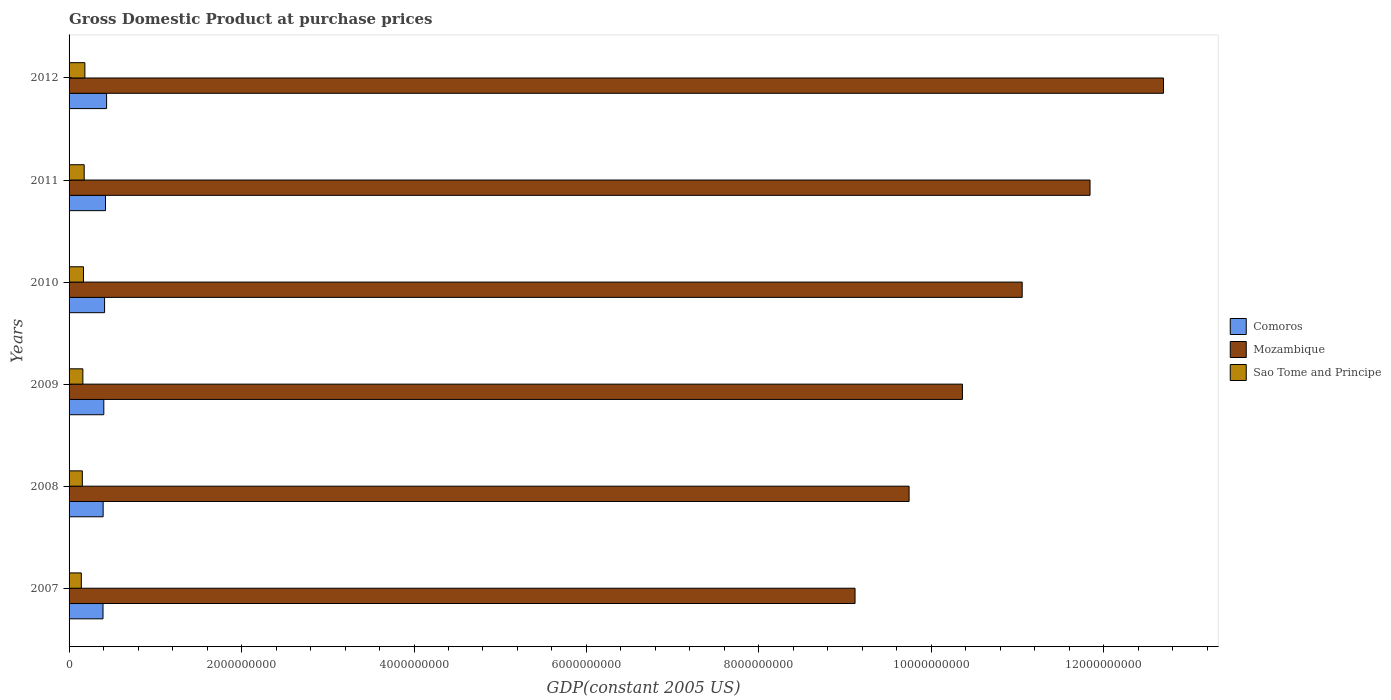How many different coloured bars are there?
Provide a short and direct response. 3. How many groups of bars are there?
Make the answer very short. 6. Are the number of bars on each tick of the Y-axis equal?
Your response must be concise. Yes. How many bars are there on the 3rd tick from the top?
Your answer should be very brief. 3. How many bars are there on the 5th tick from the bottom?
Your answer should be very brief. 3. What is the label of the 6th group of bars from the top?
Provide a short and direct response. 2007. In how many cases, is the number of bars for a given year not equal to the number of legend labels?
Provide a short and direct response. 0. What is the GDP at purchase prices in Comoros in 2008?
Your response must be concise. 3.95e+08. Across all years, what is the maximum GDP at purchase prices in Sao Tome and Principe?
Offer a terse response. 1.83e+08. Across all years, what is the minimum GDP at purchase prices in Sao Tome and Principe?
Give a very brief answer. 1.42e+08. In which year was the GDP at purchase prices in Mozambique maximum?
Your answer should be compact. 2012. What is the total GDP at purchase prices in Sao Tome and Principe in the graph?
Offer a very short reply. 9.82e+08. What is the difference between the GDP at purchase prices in Mozambique in 2007 and that in 2012?
Your response must be concise. -3.58e+09. What is the difference between the GDP at purchase prices in Comoros in 2010 and the GDP at purchase prices in Mozambique in 2012?
Offer a very short reply. -1.23e+1. What is the average GDP at purchase prices in Sao Tome and Principe per year?
Your answer should be compact. 1.64e+08. In the year 2007, what is the difference between the GDP at purchase prices in Mozambique and GDP at purchase prices in Sao Tome and Principe?
Your answer should be very brief. 8.97e+09. In how many years, is the GDP at purchase prices in Mozambique greater than 6800000000 US$?
Offer a terse response. 6. What is the ratio of the GDP at purchase prices in Mozambique in 2009 to that in 2012?
Your response must be concise. 0.82. Is the GDP at purchase prices in Mozambique in 2010 less than that in 2012?
Your answer should be very brief. Yes. Is the difference between the GDP at purchase prices in Mozambique in 2009 and 2010 greater than the difference between the GDP at purchase prices in Sao Tome and Principe in 2009 and 2010?
Provide a short and direct response. No. What is the difference between the highest and the second highest GDP at purchase prices in Sao Tome and Principe?
Offer a terse response. 8.04e+06. What is the difference between the highest and the lowest GDP at purchase prices in Sao Tome and Principe?
Offer a very short reply. 4.11e+07. Is the sum of the GDP at purchase prices in Mozambique in 2010 and 2012 greater than the maximum GDP at purchase prices in Sao Tome and Principe across all years?
Make the answer very short. Yes. What does the 3rd bar from the top in 2009 represents?
Make the answer very short. Comoros. What does the 1st bar from the bottom in 2010 represents?
Offer a terse response. Comoros. How many bars are there?
Your answer should be compact. 18. How many years are there in the graph?
Make the answer very short. 6. What is the difference between two consecutive major ticks on the X-axis?
Give a very brief answer. 2.00e+09. Are the values on the major ticks of X-axis written in scientific E-notation?
Provide a short and direct response. No. Does the graph contain any zero values?
Ensure brevity in your answer.  No. Does the graph contain grids?
Provide a succinct answer. No. How are the legend labels stacked?
Offer a terse response. Vertical. What is the title of the graph?
Ensure brevity in your answer.  Gross Domestic Product at purchase prices. Does "Kiribati" appear as one of the legend labels in the graph?
Provide a short and direct response. No. What is the label or title of the X-axis?
Your answer should be very brief. GDP(constant 2005 US). What is the label or title of the Y-axis?
Your answer should be compact. Years. What is the GDP(constant 2005 US) of Comoros in 2007?
Your answer should be compact. 3.94e+08. What is the GDP(constant 2005 US) in Mozambique in 2007?
Keep it short and to the point. 9.11e+09. What is the GDP(constant 2005 US) in Sao Tome and Principe in 2007?
Make the answer very short. 1.42e+08. What is the GDP(constant 2005 US) in Comoros in 2008?
Provide a succinct answer. 3.95e+08. What is the GDP(constant 2005 US) in Mozambique in 2008?
Your response must be concise. 9.74e+09. What is the GDP(constant 2005 US) of Sao Tome and Principe in 2008?
Provide a short and direct response. 1.54e+08. What is the GDP(constant 2005 US) of Comoros in 2009?
Offer a very short reply. 4.03e+08. What is the GDP(constant 2005 US) in Mozambique in 2009?
Your answer should be very brief. 1.04e+1. What is the GDP(constant 2005 US) in Sao Tome and Principe in 2009?
Your answer should be compact. 1.60e+08. What is the GDP(constant 2005 US) in Comoros in 2010?
Offer a terse response. 4.12e+08. What is the GDP(constant 2005 US) in Mozambique in 2010?
Your response must be concise. 1.11e+1. What is the GDP(constant 2005 US) of Sao Tome and Principe in 2010?
Ensure brevity in your answer.  1.67e+08. What is the GDP(constant 2005 US) in Comoros in 2011?
Your response must be concise. 4.22e+08. What is the GDP(constant 2005 US) of Mozambique in 2011?
Your answer should be very brief. 1.18e+1. What is the GDP(constant 2005 US) in Sao Tome and Principe in 2011?
Your answer should be compact. 1.75e+08. What is the GDP(constant 2005 US) in Comoros in 2012?
Provide a succinct answer. 4.35e+08. What is the GDP(constant 2005 US) of Mozambique in 2012?
Your answer should be compact. 1.27e+1. What is the GDP(constant 2005 US) of Sao Tome and Principe in 2012?
Make the answer very short. 1.83e+08. Across all years, what is the maximum GDP(constant 2005 US) of Comoros?
Your answer should be compact. 4.35e+08. Across all years, what is the maximum GDP(constant 2005 US) of Mozambique?
Provide a succinct answer. 1.27e+1. Across all years, what is the maximum GDP(constant 2005 US) in Sao Tome and Principe?
Provide a short and direct response. 1.83e+08. Across all years, what is the minimum GDP(constant 2005 US) of Comoros?
Provide a succinct answer. 3.94e+08. Across all years, what is the minimum GDP(constant 2005 US) in Mozambique?
Your answer should be very brief. 9.11e+09. Across all years, what is the minimum GDP(constant 2005 US) in Sao Tome and Principe?
Give a very brief answer. 1.42e+08. What is the total GDP(constant 2005 US) in Comoros in the graph?
Provide a short and direct response. 2.46e+09. What is the total GDP(constant 2005 US) in Mozambique in the graph?
Keep it short and to the point. 6.48e+1. What is the total GDP(constant 2005 US) of Sao Tome and Principe in the graph?
Offer a terse response. 9.82e+08. What is the difference between the GDP(constant 2005 US) in Comoros in 2007 and that in 2008?
Your response must be concise. -1.58e+06. What is the difference between the GDP(constant 2005 US) of Mozambique in 2007 and that in 2008?
Ensure brevity in your answer.  -6.27e+08. What is the difference between the GDP(constant 2005 US) in Sao Tome and Principe in 2007 and that in 2008?
Give a very brief answer. -1.16e+07. What is the difference between the GDP(constant 2005 US) in Comoros in 2007 and that in 2009?
Your response must be concise. -9.28e+06. What is the difference between the GDP(constant 2005 US) of Mozambique in 2007 and that in 2009?
Provide a succinct answer. -1.25e+09. What is the difference between the GDP(constant 2005 US) of Sao Tome and Principe in 2007 and that in 2009?
Provide a succinct answer. -1.78e+07. What is the difference between the GDP(constant 2005 US) of Comoros in 2007 and that in 2010?
Provide a succinct answer. -1.81e+07. What is the difference between the GDP(constant 2005 US) of Mozambique in 2007 and that in 2010?
Your answer should be compact. -1.94e+09. What is the difference between the GDP(constant 2005 US) in Sao Tome and Principe in 2007 and that in 2010?
Provide a short and direct response. -2.50e+07. What is the difference between the GDP(constant 2005 US) of Comoros in 2007 and that in 2011?
Provide a short and direct response. -2.88e+07. What is the difference between the GDP(constant 2005 US) in Mozambique in 2007 and that in 2011?
Ensure brevity in your answer.  -2.73e+09. What is the difference between the GDP(constant 2005 US) in Sao Tome and Principe in 2007 and that in 2011?
Ensure brevity in your answer.  -3.31e+07. What is the difference between the GDP(constant 2005 US) of Comoros in 2007 and that in 2012?
Provide a succinct answer. -4.15e+07. What is the difference between the GDP(constant 2005 US) of Mozambique in 2007 and that in 2012?
Provide a short and direct response. -3.58e+09. What is the difference between the GDP(constant 2005 US) in Sao Tome and Principe in 2007 and that in 2012?
Provide a succinct answer. -4.11e+07. What is the difference between the GDP(constant 2005 US) in Comoros in 2008 and that in 2009?
Your answer should be very brief. -7.71e+06. What is the difference between the GDP(constant 2005 US) in Mozambique in 2008 and that in 2009?
Give a very brief answer. -6.19e+08. What is the difference between the GDP(constant 2005 US) of Sao Tome and Principe in 2008 and that in 2009?
Offer a terse response. -6.18e+06. What is the difference between the GDP(constant 2005 US) in Comoros in 2008 and that in 2010?
Your answer should be very brief. -1.66e+07. What is the difference between the GDP(constant 2005 US) of Mozambique in 2008 and that in 2010?
Keep it short and to the point. -1.31e+09. What is the difference between the GDP(constant 2005 US) in Sao Tome and Principe in 2008 and that in 2010?
Make the answer very short. -1.33e+07. What is the difference between the GDP(constant 2005 US) in Comoros in 2008 and that in 2011?
Offer a terse response. -2.73e+07. What is the difference between the GDP(constant 2005 US) of Mozambique in 2008 and that in 2011?
Your answer should be compact. -2.10e+09. What is the difference between the GDP(constant 2005 US) of Sao Tome and Principe in 2008 and that in 2011?
Ensure brevity in your answer.  -2.14e+07. What is the difference between the GDP(constant 2005 US) in Comoros in 2008 and that in 2012?
Keep it short and to the point. -3.99e+07. What is the difference between the GDP(constant 2005 US) in Mozambique in 2008 and that in 2012?
Your answer should be very brief. -2.95e+09. What is the difference between the GDP(constant 2005 US) of Sao Tome and Principe in 2008 and that in 2012?
Provide a short and direct response. -2.95e+07. What is the difference between the GDP(constant 2005 US) in Comoros in 2009 and that in 2010?
Your response must be concise. -8.86e+06. What is the difference between the GDP(constant 2005 US) in Mozambique in 2009 and that in 2010?
Provide a succinct answer. -6.93e+08. What is the difference between the GDP(constant 2005 US) of Sao Tome and Principe in 2009 and that in 2010?
Offer a very short reply. -7.17e+06. What is the difference between the GDP(constant 2005 US) of Comoros in 2009 and that in 2011?
Your answer should be very brief. -1.96e+07. What is the difference between the GDP(constant 2005 US) of Mozambique in 2009 and that in 2011?
Keep it short and to the point. -1.48e+09. What is the difference between the GDP(constant 2005 US) of Sao Tome and Principe in 2009 and that in 2011?
Give a very brief answer. -1.52e+07. What is the difference between the GDP(constant 2005 US) in Comoros in 2009 and that in 2012?
Keep it short and to the point. -3.22e+07. What is the difference between the GDP(constant 2005 US) of Mozambique in 2009 and that in 2012?
Give a very brief answer. -2.33e+09. What is the difference between the GDP(constant 2005 US) of Sao Tome and Principe in 2009 and that in 2012?
Offer a very short reply. -2.33e+07. What is the difference between the GDP(constant 2005 US) of Comoros in 2010 and that in 2011?
Keep it short and to the point. -1.07e+07. What is the difference between the GDP(constant 2005 US) of Mozambique in 2010 and that in 2011?
Offer a terse response. -7.87e+08. What is the difference between the GDP(constant 2005 US) in Sao Tome and Principe in 2010 and that in 2011?
Ensure brevity in your answer.  -8.07e+06. What is the difference between the GDP(constant 2005 US) in Comoros in 2010 and that in 2012?
Your answer should be compact. -2.34e+07. What is the difference between the GDP(constant 2005 US) of Mozambique in 2010 and that in 2012?
Offer a terse response. -1.64e+09. What is the difference between the GDP(constant 2005 US) in Sao Tome and Principe in 2010 and that in 2012?
Provide a succinct answer. -1.61e+07. What is the difference between the GDP(constant 2005 US) in Comoros in 2011 and that in 2012?
Give a very brief answer. -1.27e+07. What is the difference between the GDP(constant 2005 US) of Mozambique in 2011 and that in 2012?
Offer a very short reply. -8.52e+08. What is the difference between the GDP(constant 2005 US) of Sao Tome and Principe in 2011 and that in 2012?
Provide a succinct answer. -8.04e+06. What is the difference between the GDP(constant 2005 US) in Comoros in 2007 and the GDP(constant 2005 US) in Mozambique in 2008?
Make the answer very short. -9.35e+09. What is the difference between the GDP(constant 2005 US) of Comoros in 2007 and the GDP(constant 2005 US) of Sao Tome and Principe in 2008?
Provide a succinct answer. 2.40e+08. What is the difference between the GDP(constant 2005 US) of Mozambique in 2007 and the GDP(constant 2005 US) of Sao Tome and Principe in 2008?
Provide a short and direct response. 8.96e+09. What is the difference between the GDP(constant 2005 US) of Comoros in 2007 and the GDP(constant 2005 US) of Mozambique in 2009?
Offer a very short reply. -9.97e+09. What is the difference between the GDP(constant 2005 US) in Comoros in 2007 and the GDP(constant 2005 US) in Sao Tome and Principe in 2009?
Make the answer very short. 2.34e+08. What is the difference between the GDP(constant 2005 US) of Mozambique in 2007 and the GDP(constant 2005 US) of Sao Tome and Principe in 2009?
Keep it short and to the point. 8.95e+09. What is the difference between the GDP(constant 2005 US) in Comoros in 2007 and the GDP(constant 2005 US) in Mozambique in 2010?
Make the answer very short. -1.07e+1. What is the difference between the GDP(constant 2005 US) in Comoros in 2007 and the GDP(constant 2005 US) in Sao Tome and Principe in 2010?
Make the answer very short. 2.26e+08. What is the difference between the GDP(constant 2005 US) of Mozambique in 2007 and the GDP(constant 2005 US) of Sao Tome and Principe in 2010?
Offer a terse response. 8.95e+09. What is the difference between the GDP(constant 2005 US) in Comoros in 2007 and the GDP(constant 2005 US) in Mozambique in 2011?
Offer a terse response. -1.14e+1. What is the difference between the GDP(constant 2005 US) of Comoros in 2007 and the GDP(constant 2005 US) of Sao Tome and Principe in 2011?
Provide a short and direct response. 2.18e+08. What is the difference between the GDP(constant 2005 US) in Mozambique in 2007 and the GDP(constant 2005 US) in Sao Tome and Principe in 2011?
Your response must be concise. 8.94e+09. What is the difference between the GDP(constant 2005 US) in Comoros in 2007 and the GDP(constant 2005 US) in Mozambique in 2012?
Your answer should be very brief. -1.23e+1. What is the difference between the GDP(constant 2005 US) of Comoros in 2007 and the GDP(constant 2005 US) of Sao Tome and Principe in 2012?
Provide a succinct answer. 2.10e+08. What is the difference between the GDP(constant 2005 US) in Mozambique in 2007 and the GDP(constant 2005 US) in Sao Tome and Principe in 2012?
Ensure brevity in your answer.  8.93e+09. What is the difference between the GDP(constant 2005 US) of Comoros in 2008 and the GDP(constant 2005 US) of Mozambique in 2009?
Ensure brevity in your answer.  -9.97e+09. What is the difference between the GDP(constant 2005 US) in Comoros in 2008 and the GDP(constant 2005 US) in Sao Tome and Principe in 2009?
Your response must be concise. 2.35e+08. What is the difference between the GDP(constant 2005 US) in Mozambique in 2008 and the GDP(constant 2005 US) in Sao Tome and Principe in 2009?
Make the answer very short. 9.58e+09. What is the difference between the GDP(constant 2005 US) in Comoros in 2008 and the GDP(constant 2005 US) in Mozambique in 2010?
Provide a succinct answer. -1.07e+1. What is the difference between the GDP(constant 2005 US) in Comoros in 2008 and the GDP(constant 2005 US) in Sao Tome and Principe in 2010?
Your answer should be compact. 2.28e+08. What is the difference between the GDP(constant 2005 US) in Mozambique in 2008 and the GDP(constant 2005 US) in Sao Tome and Principe in 2010?
Your answer should be very brief. 9.57e+09. What is the difference between the GDP(constant 2005 US) in Comoros in 2008 and the GDP(constant 2005 US) in Mozambique in 2011?
Your response must be concise. -1.14e+1. What is the difference between the GDP(constant 2005 US) of Comoros in 2008 and the GDP(constant 2005 US) of Sao Tome and Principe in 2011?
Provide a short and direct response. 2.20e+08. What is the difference between the GDP(constant 2005 US) in Mozambique in 2008 and the GDP(constant 2005 US) in Sao Tome and Principe in 2011?
Give a very brief answer. 9.57e+09. What is the difference between the GDP(constant 2005 US) in Comoros in 2008 and the GDP(constant 2005 US) in Mozambique in 2012?
Your answer should be very brief. -1.23e+1. What is the difference between the GDP(constant 2005 US) in Comoros in 2008 and the GDP(constant 2005 US) in Sao Tome and Principe in 2012?
Your answer should be very brief. 2.12e+08. What is the difference between the GDP(constant 2005 US) in Mozambique in 2008 and the GDP(constant 2005 US) in Sao Tome and Principe in 2012?
Keep it short and to the point. 9.56e+09. What is the difference between the GDP(constant 2005 US) in Comoros in 2009 and the GDP(constant 2005 US) in Mozambique in 2010?
Give a very brief answer. -1.07e+1. What is the difference between the GDP(constant 2005 US) of Comoros in 2009 and the GDP(constant 2005 US) of Sao Tome and Principe in 2010?
Your answer should be compact. 2.36e+08. What is the difference between the GDP(constant 2005 US) in Mozambique in 2009 and the GDP(constant 2005 US) in Sao Tome and Principe in 2010?
Offer a terse response. 1.02e+1. What is the difference between the GDP(constant 2005 US) of Comoros in 2009 and the GDP(constant 2005 US) of Mozambique in 2011?
Offer a terse response. -1.14e+1. What is the difference between the GDP(constant 2005 US) in Comoros in 2009 and the GDP(constant 2005 US) in Sao Tome and Principe in 2011?
Give a very brief answer. 2.28e+08. What is the difference between the GDP(constant 2005 US) in Mozambique in 2009 and the GDP(constant 2005 US) in Sao Tome and Principe in 2011?
Offer a terse response. 1.02e+1. What is the difference between the GDP(constant 2005 US) of Comoros in 2009 and the GDP(constant 2005 US) of Mozambique in 2012?
Make the answer very short. -1.23e+1. What is the difference between the GDP(constant 2005 US) of Comoros in 2009 and the GDP(constant 2005 US) of Sao Tome and Principe in 2012?
Ensure brevity in your answer.  2.20e+08. What is the difference between the GDP(constant 2005 US) of Mozambique in 2009 and the GDP(constant 2005 US) of Sao Tome and Principe in 2012?
Offer a terse response. 1.02e+1. What is the difference between the GDP(constant 2005 US) in Comoros in 2010 and the GDP(constant 2005 US) in Mozambique in 2011?
Offer a very short reply. -1.14e+1. What is the difference between the GDP(constant 2005 US) of Comoros in 2010 and the GDP(constant 2005 US) of Sao Tome and Principe in 2011?
Provide a succinct answer. 2.36e+08. What is the difference between the GDP(constant 2005 US) in Mozambique in 2010 and the GDP(constant 2005 US) in Sao Tome and Principe in 2011?
Your response must be concise. 1.09e+1. What is the difference between the GDP(constant 2005 US) in Comoros in 2010 and the GDP(constant 2005 US) in Mozambique in 2012?
Give a very brief answer. -1.23e+1. What is the difference between the GDP(constant 2005 US) of Comoros in 2010 and the GDP(constant 2005 US) of Sao Tome and Principe in 2012?
Your answer should be very brief. 2.28e+08. What is the difference between the GDP(constant 2005 US) of Mozambique in 2010 and the GDP(constant 2005 US) of Sao Tome and Principe in 2012?
Make the answer very short. 1.09e+1. What is the difference between the GDP(constant 2005 US) of Comoros in 2011 and the GDP(constant 2005 US) of Mozambique in 2012?
Ensure brevity in your answer.  -1.23e+1. What is the difference between the GDP(constant 2005 US) of Comoros in 2011 and the GDP(constant 2005 US) of Sao Tome and Principe in 2012?
Keep it short and to the point. 2.39e+08. What is the difference between the GDP(constant 2005 US) of Mozambique in 2011 and the GDP(constant 2005 US) of Sao Tome and Principe in 2012?
Your answer should be compact. 1.17e+1. What is the average GDP(constant 2005 US) of Comoros per year?
Your response must be concise. 4.10e+08. What is the average GDP(constant 2005 US) in Mozambique per year?
Make the answer very short. 1.08e+1. What is the average GDP(constant 2005 US) in Sao Tome and Principe per year?
Offer a very short reply. 1.64e+08. In the year 2007, what is the difference between the GDP(constant 2005 US) in Comoros and GDP(constant 2005 US) in Mozambique?
Keep it short and to the point. -8.72e+09. In the year 2007, what is the difference between the GDP(constant 2005 US) of Comoros and GDP(constant 2005 US) of Sao Tome and Principe?
Your answer should be compact. 2.51e+08. In the year 2007, what is the difference between the GDP(constant 2005 US) in Mozambique and GDP(constant 2005 US) in Sao Tome and Principe?
Offer a terse response. 8.97e+09. In the year 2008, what is the difference between the GDP(constant 2005 US) in Comoros and GDP(constant 2005 US) in Mozambique?
Provide a succinct answer. -9.35e+09. In the year 2008, what is the difference between the GDP(constant 2005 US) of Comoros and GDP(constant 2005 US) of Sao Tome and Principe?
Provide a short and direct response. 2.41e+08. In the year 2008, what is the difference between the GDP(constant 2005 US) in Mozambique and GDP(constant 2005 US) in Sao Tome and Principe?
Your response must be concise. 9.59e+09. In the year 2009, what is the difference between the GDP(constant 2005 US) of Comoros and GDP(constant 2005 US) of Mozambique?
Make the answer very short. -9.96e+09. In the year 2009, what is the difference between the GDP(constant 2005 US) of Comoros and GDP(constant 2005 US) of Sao Tome and Principe?
Offer a terse response. 2.43e+08. In the year 2009, what is the difference between the GDP(constant 2005 US) of Mozambique and GDP(constant 2005 US) of Sao Tome and Principe?
Give a very brief answer. 1.02e+1. In the year 2010, what is the difference between the GDP(constant 2005 US) in Comoros and GDP(constant 2005 US) in Mozambique?
Keep it short and to the point. -1.06e+1. In the year 2010, what is the difference between the GDP(constant 2005 US) in Comoros and GDP(constant 2005 US) in Sao Tome and Principe?
Ensure brevity in your answer.  2.45e+08. In the year 2010, what is the difference between the GDP(constant 2005 US) in Mozambique and GDP(constant 2005 US) in Sao Tome and Principe?
Ensure brevity in your answer.  1.09e+1. In the year 2011, what is the difference between the GDP(constant 2005 US) in Comoros and GDP(constant 2005 US) in Mozambique?
Offer a terse response. -1.14e+1. In the year 2011, what is the difference between the GDP(constant 2005 US) in Comoros and GDP(constant 2005 US) in Sao Tome and Principe?
Provide a succinct answer. 2.47e+08. In the year 2011, what is the difference between the GDP(constant 2005 US) in Mozambique and GDP(constant 2005 US) in Sao Tome and Principe?
Make the answer very short. 1.17e+1. In the year 2012, what is the difference between the GDP(constant 2005 US) of Comoros and GDP(constant 2005 US) of Mozambique?
Your response must be concise. -1.23e+1. In the year 2012, what is the difference between the GDP(constant 2005 US) of Comoros and GDP(constant 2005 US) of Sao Tome and Principe?
Provide a succinct answer. 2.52e+08. In the year 2012, what is the difference between the GDP(constant 2005 US) in Mozambique and GDP(constant 2005 US) in Sao Tome and Principe?
Offer a terse response. 1.25e+1. What is the ratio of the GDP(constant 2005 US) in Mozambique in 2007 to that in 2008?
Make the answer very short. 0.94. What is the ratio of the GDP(constant 2005 US) in Sao Tome and Principe in 2007 to that in 2008?
Offer a very short reply. 0.92. What is the ratio of the GDP(constant 2005 US) of Comoros in 2007 to that in 2009?
Ensure brevity in your answer.  0.98. What is the ratio of the GDP(constant 2005 US) in Mozambique in 2007 to that in 2009?
Ensure brevity in your answer.  0.88. What is the ratio of the GDP(constant 2005 US) of Sao Tome and Principe in 2007 to that in 2009?
Provide a succinct answer. 0.89. What is the ratio of the GDP(constant 2005 US) of Comoros in 2007 to that in 2010?
Your answer should be compact. 0.96. What is the ratio of the GDP(constant 2005 US) in Mozambique in 2007 to that in 2010?
Give a very brief answer. 0.82. What is the ratio of the GDP(constant 2005 US) in Sao Tome and Principe in 2007 to that in 2010?
Make the answer very short. 0.85. What is the ratio of the GDP(constant 2005 US) of Comoros in 2007 to that in 2011?
Offer a terse response. 0.93. What is the ratio of the GDP(constant 2005 US) of Mozambique in 2007 to that in 2011?
Offer a terse response. 0.77. What is the ratio of the GDP(constant 2005 US) in Sao Tome and Principe in 2007 to that in 2011?
Your answer should be very brief. 0.81. What is the ratio of the GDP(constant 2005 US) of Comoros in 2007 to that in 2012?
Give a very brief answer. 0.9. What is the ratio of the GDP(constant 2005 US) of Mozambique in 2007 to that in 2012?
Provide a short and direct response. 0.72. What is the ratio of the GDP(constant 2005 US) of Sao Tome and Principe in 2007 to that in 2012?
Provide a succinct answer. 0.78. What is the ratio of the GDP(constant 2005 US) in Comoros in 2008 to that in 2009?
Offer a terse response. 0.98. What is the ratio of the GDP(constant 2005 US) in Mozambique in 2008 to that in 2009?
Give a very brief answer. 0.94. What is the ratio of the GDP(constant 2005 US) of Sao Tome and Principe in 2008 to that in 2009?
Your answer should be compact. 0.96. What is the ratio of the GDP(constant 2005 US) of Comoros in 2008 to that in 2010?
Give a very brief answer. 0.96. What is the ratio of the GDP(constant 2005 US) in Mozambique in 2008 to that in 2010?
Provide a short and direct response. 0.88. What is the ratio of the GDP(constant 2005 US) of Sao Tome and Principe in 2008 to that in 2010?
Keep it short and to the point. 0.92. What is the ratio of the GDP(constant 2005 US) in Comoros in 2008 to that in 2011?
Give a very brief answer. 0.94. What is the ratio of the GDP(constant 2005 US) in Mozambique in 2008 to that in 2011?
Provide a short and direct response. 0.82. What is the ratio of the GDP(constant 2005 US) of Sao Tome and Principe in 2008 to that in 2011?
Provide a succinct answer. 0.88. What is the ratio of the GDP(constant 2005 US) of Comoros in 2008 to that in 2012?
Ensure brevity in your answer.  0.91. What is the ratio of the GDP(constant 2005 US) in Mozambique in 2008 to that in 2012?
Your answer should be compact. 0.77. What is the ratio of the GDP(constant 2005 US) in Sao Tome and Principe in 2008 to that in 2012?
Offer a terse response. 0.84. What is the ratio of the GDP(constant 2005 US) of Comoros in 2009 to that in 2010?
Your response must be concise. 0.98. What is the ratio of the GDP(constant 2005 US) in Mozambique in 2009 to that in 2010?
Offer a very short reply. 0.94. What is the ratio of the GDP(constant 2005 US) in Sao Tome and Principe in 2009 to that in 2010?
Your response must be concise. 0.96. What is the ratio of the GDP(constant 2005 US) in Comoros in 2009 to that in 2011?
Offer a terse response. 0.95. What is the ratio of the GDP(constant 2005 US) in Sao Tome and Principe in 2009 to that in 2011?
Provide a succinct answer. 0.91. What is the ratio of the GDP(constant 2005 US) in Comoros in 2009 to that in 2012?
Make the answer very short. 0.93. What is the ratio of the GDP(constant 2005 US) of Mozambique in 2009 to that in 2012?
Keep it short and to the point. 0.82. What is the ratio of the GDP(constant 2005 US) in Sao Tome and Principe in 2009 to that in 2012?
Make the answer very short. 0.87. What is the ratio of the GDP(constant 2005 US) in Comoros in 2010 to that in 2011?
Keep it short and to the point. 0.97. What is the ratio of the GDP(constant 2005 US) in Mozambique in 2010 to that in 2011?
Keep it short and to the point. 0.93. What is the ratio of the GDP(constant 2005 US) of Sao Tome and Principe in 2010 to that in 2011?
Ensure brevity in your answer.  0.95. What is the ratio of the GDP(constant 2005 US) of Comoros in 2010 to that in 2012?
Your answer should be compact. 0.95. What is the ratio of the GDP(constant 2005 US) of Mozambique in 2010 to that in 2012?
Offer a terse response. 0.87. What is the ratio of the GDP(constant 2005 US) of Sao Tome and Principe in 2010 to that in 2012?
Keep it short and to the point. 0.91. What is the ratio of the GDP(constant 2005 US) in Comoros in 2011 to that in 2012?
Ensure brevity in your answer.  0.97. What is the ratio of the GDP(constant 2005 US) of Mozambique in 2011 to that in 2012?
Keep it short and to the point. 0.93. What is the ratio of the GDP(constant 2005 US) of Sao Tome and Principe in 2011 to that in 2012?
Provide a short and direct response. 0.96. What is the difference between the highest and the second highest GDP(constant 2005 US) of Comoros?
Your answer should be very brief. 1.27e+07. What is the difference between the highest and the second highest GDP(constant 2005 US) of Mozambique?
Offer a very short reply. 8.52e+08. What is the difference between the highest and the second highest GDP(constant 2005 US) of Sao Tome and Principe?
Make the answer very short. 8.04e+06. What is the difference between the highest and the lowest GDP(constant 2005 US) of Comoros?
Offer a very short reply. 4.15e+07. What is the difference between the highest and the lowest GDP(constant 2005 US) in Mozambique?
Keep it short and to the point. 3.58e+09. What is the difference between the highest and the lowest GDP(constant 2005 US) of Sao Tome and Principe?
Ensure brevity in your answer.  4.11e+07. 